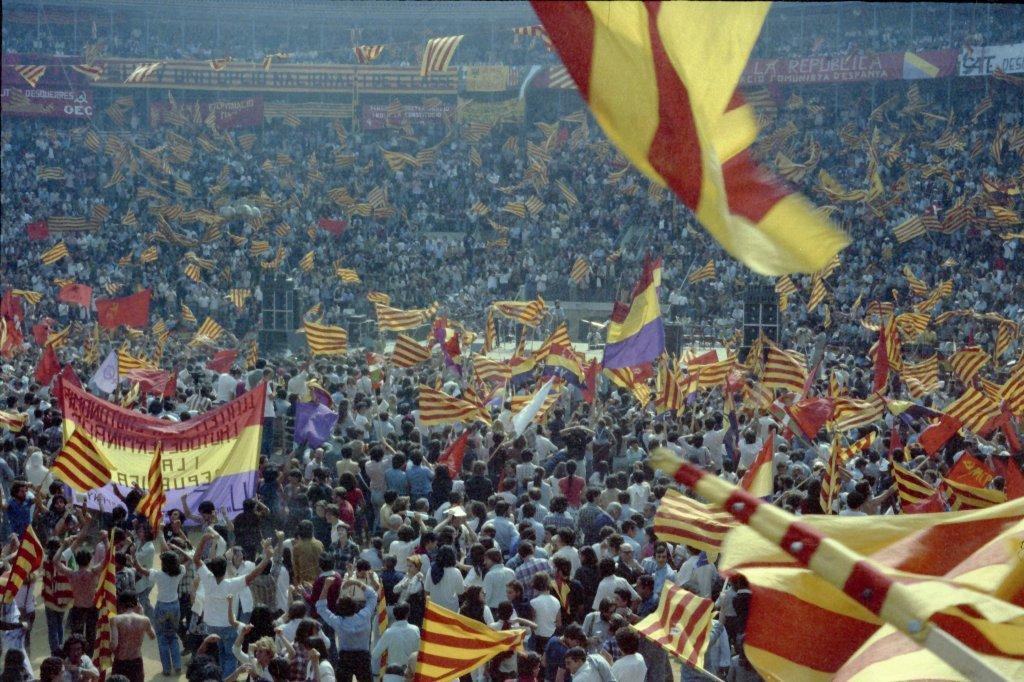Who or what is present in the image? There are people in the image. What are the people doing in the image? The people are standing and waving flags. What type of market can be seen in the image? There is no market present in the image; it features people standing and waving flags. 